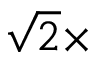<formula> <loc_0><loc_0><loc_500><loc_500>\sqrt { 2 } \times</formula> 